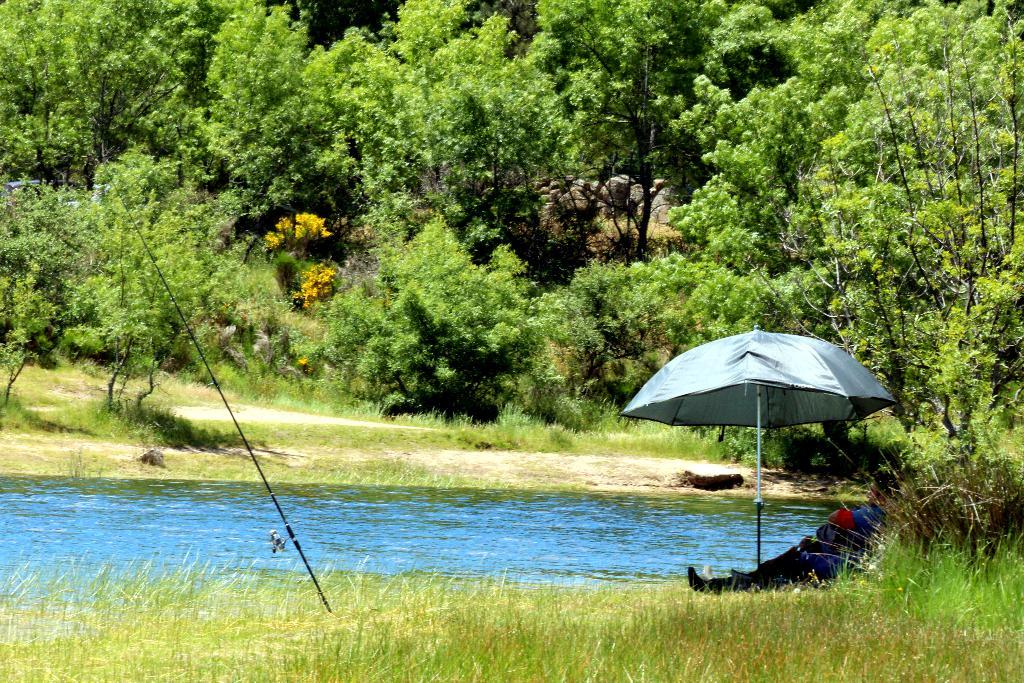What is the main natural element present in the image? There is water in the image. What type of vegetation can be seen in the image? There is grass and trees in the image. What object is present for protection from the sun or rain? There is an umbrella in the image. What is the person in the image doing? There is a person sitting in the image. What type of club is the person holding in the image? There is no club present in the image; the person is sitting and not holding any object. 